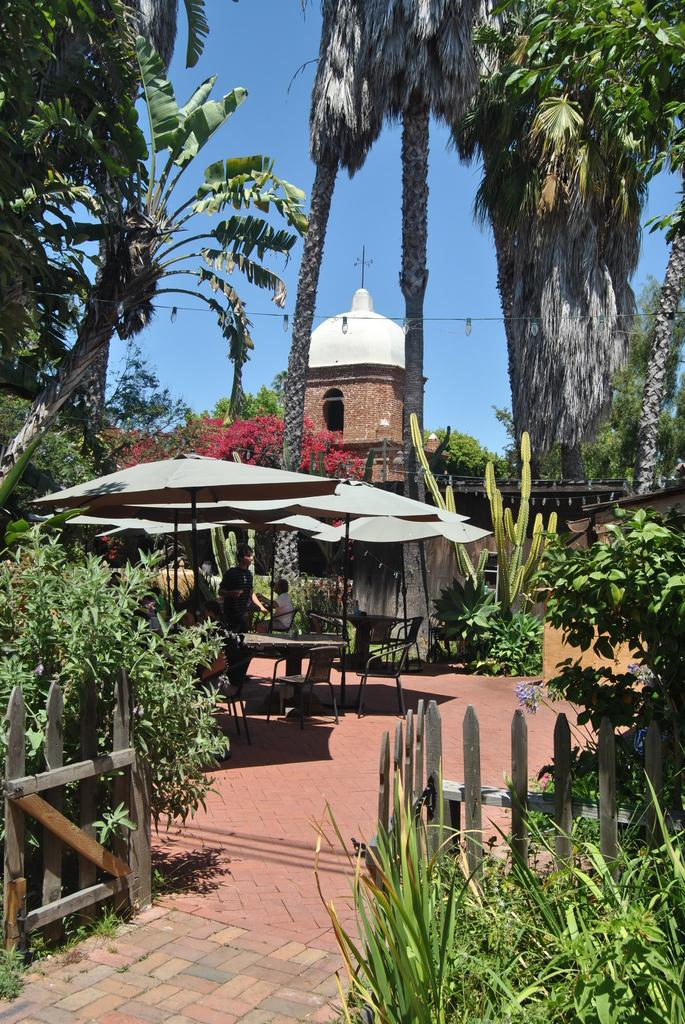What type of living organisms can be seen in the image? Plants and trees are visible in the image. What color shades can be observed in the image? There are white color shades in the image. What can be seen in the background of the image? There is a building and the sky visible in the background of the image. What type of furniture is present in the image? There are chairs and a table in the image. Are there any people present in the image? Yes, there are people in the image. What type of creature is sitting on the table in the image? There is no creature sitting on the table in the image; it features chairs and a table with people. What is the name of the mom in the image? There is no specific person identified as a mom in the image, as it only shows a group of people. 